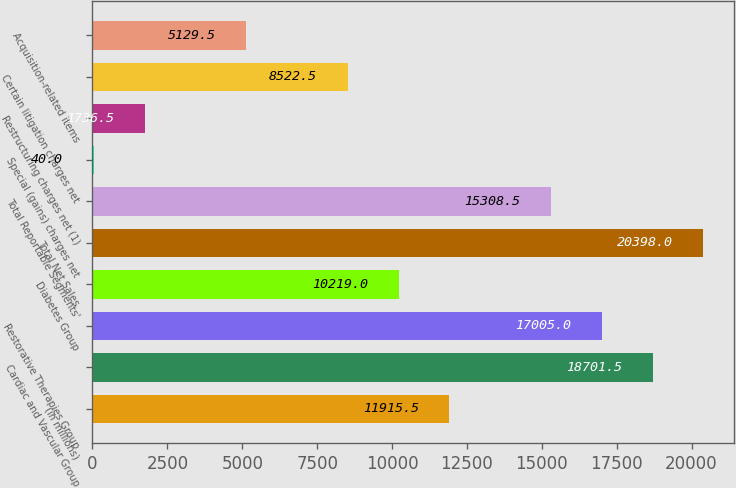Convert chart. <chart><loc_0><loc_0><loc_500><loc_500><bar_chart><fcel>(in millions)<fcel>Cardiac and Vascular Group<fcel>Restorative Therapies Group<fcel>Diabetes Group<fcel>Total Net Sales<fcel>Total Reportable Segments'<fcel>Special (gains) charges net<fcel>Restructuring charges net (1)<fcel>Certain litigation charges net<fcel>Acquisition-related items<nl><fcel>11915.5<fcel>18701.5<fcel>17005<fcel>10219<fcel>20398<fcel>15308.5<fcel>40<fcel>1736.5<fcel>8522.5<fcel>5129.5<nl></chart> 